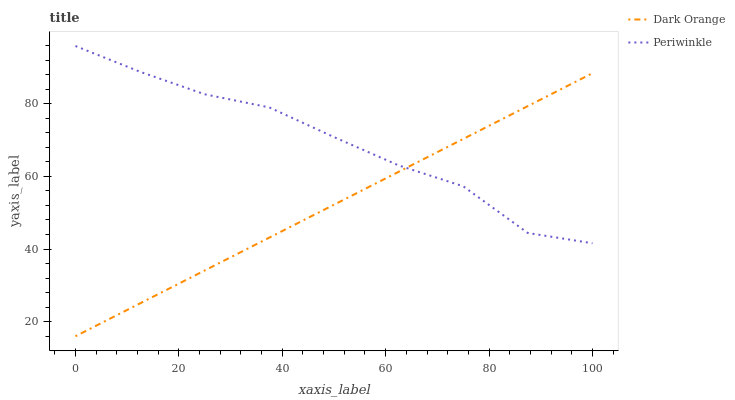Does Periwinkle have the minimum area under the curve?
Answer yes or no. No. Is Periwinkle the smoothest?
Answer yes or no. No. Does Periwinkle have the lowest value?
Answer yes or no. No. 